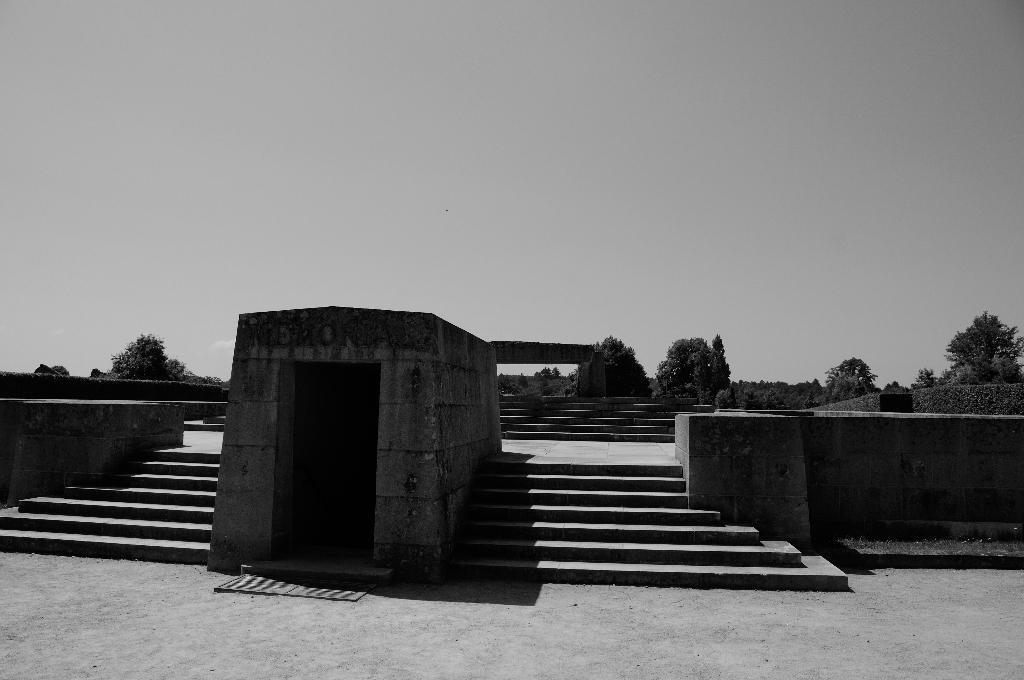Can you describe this image briefly? In this image in the center there are some stairs, and in the background there are some trees. On the right side and left side there is a wall, at the bottom there is walkway. At the top of the image there is sky. 